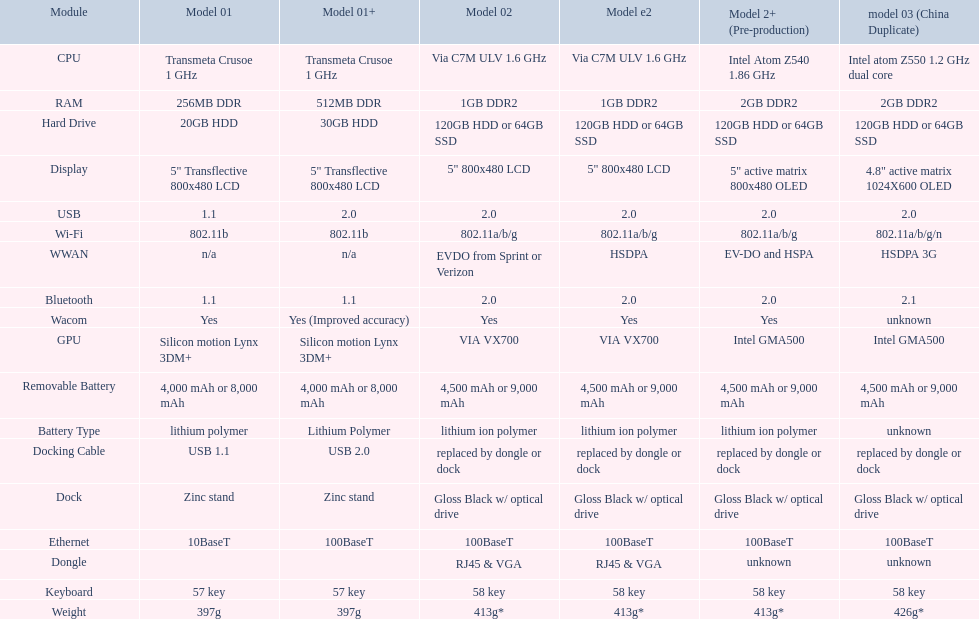What is the average number of models that have usb 2.0? 5. 